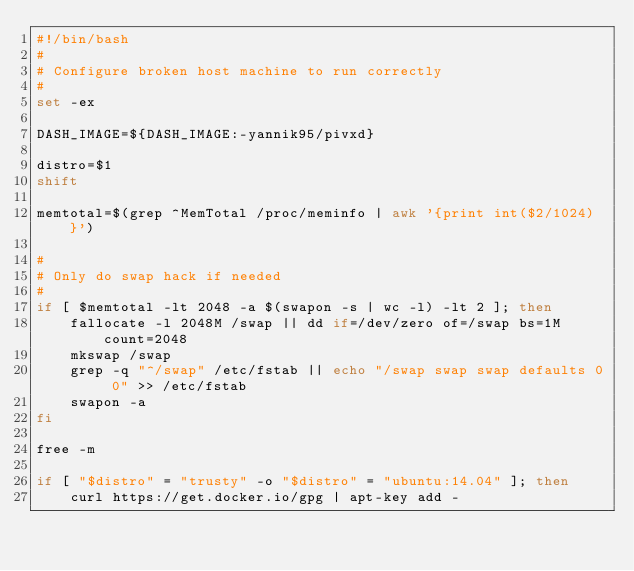<code> <loc_0><loc_0><loc_500><loc_500><_Bash_>#!/bin/bash
#
# Configure broken host machine to run correctly
#
set -ex

DASH_IMAGE=${DASH_IMAGE:-yannik95/pivxd}

distro=$1
shift

memtotal=$(grep ^MemTotal /proc/meminfo | awk '{print int($2/1024) }')

#
# Only do swap hack if needed
#
if [ $memtotal -lt 2048 -a $(swapon -s | wc -l) -lt 2 ]; then
    fallocate -l 2048M /swap || dd if=/dev/zero of=/swap bs=1M count=2048
    mkswap /swap
    grep -q "^/swap" /etc/fstab || echo "/swap swap swap defaults 0 0" >> /etc/fstab
    swapon -a
fi

free -m

if [ "$distro" = "trusty" -o "$distro" = "ubuntu:14.04" ]; then
    curl https://get.docker.io/gpg | apt-key add -</code> 